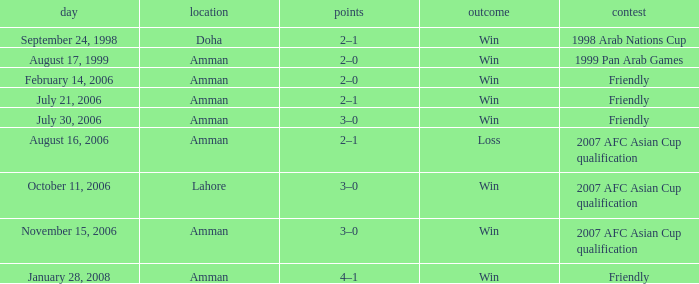What was the score of the friendly match at Amman on February 14, 2006? 2–0. 